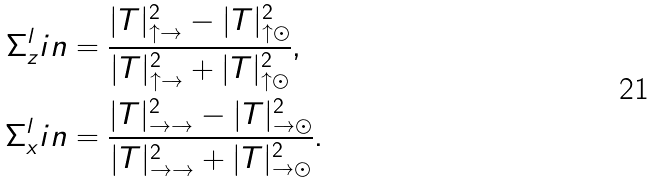Convert formula to latex. <formula><loc_0><loc_0><loc_500><loc_500>\Sigma _ { z } ^ { l } i n & = \frac { | T | ^ { 2 } _ { \uparrow \rightarrow } - | T | ^ { 2 } _ { \uparrow \odot } } { | T | ^ { 2 } _ { \uparrow \rightarrow } + | T | ^ { 2 } _ { \uparrow \odot } } , \\ \Sigma _ { x } ^ { l } i n & = \frac { | T | ^ { 2 } _ { \rightarrow \rightarrow } - | T | ^ { 2 } _ { \rightarrow \odot } } { | T | ^ { 2 } _ { \rightarrow \rightarrow } + | T | ^ { 2 } _ { \rightarrow \odot } } .</formula> 